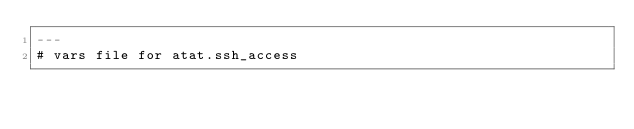<code> <loc_0><loc_0><loc_500><loc_500><_YAML_>---
# vars file for atat.ssh_access
</code> 